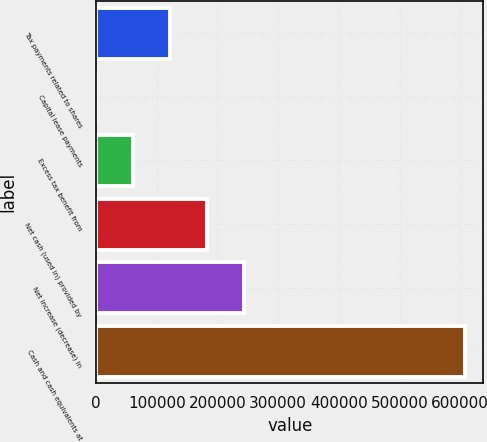Convert chart. <chart><loc_0><loc_0><loc_500><loc_500><bar_chart><fcel>Tax payments related to shares<fcel>Capital lease payments<fcel>Excess tax benefit from<fcel>Net cash (used in) provided by<fcel>Net increase (decrease) in<fcel>Cash and cash equivalents at<nl><fcel>122046<fcel>604<fcel>61325.1<fcel>182767<fcel>243488<fcel>607815<nl></chart> 